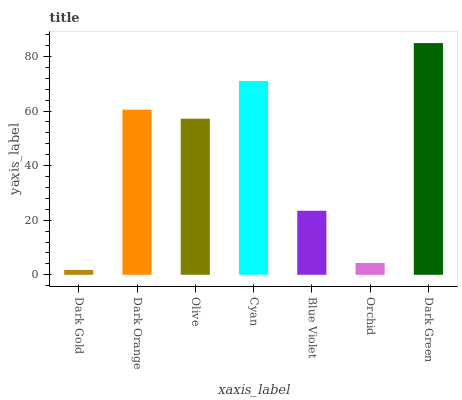Is Dark Gold the minimum?
Answer yes or no. Yes. Is Dark Green the maximum?
Answer yes or no. Yes. Is Dark Orange the minimum?
Answer yes or no. No. Is Dark Orange the maximum?
Answer yes or no. No. Is Dark Orange greater than Dark Gold?
Answer yes or no. Yes. Is Dark Gold less than Dark Orange?
Answer yes or no. Yes. Is Dark Gold greater than Dark Orange?
Answer yes or no. No. Is Dark Orange less than Dark Gold?
Answer yes or no. No. Is Olive the high median?
Answer yes or no. Yes. Is Olive the low median?
Answer yes or no. Yes. Is Dark Gold the high median?
Answer yes or no. No. Is Orchid the low median?
Answer yes or no. No. 